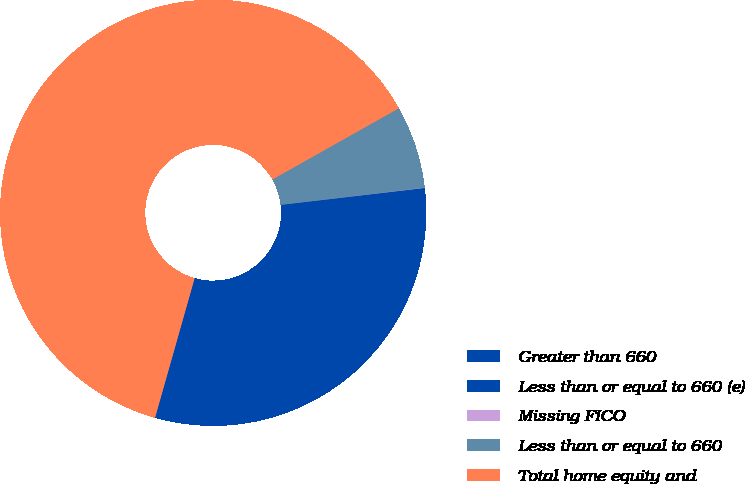Convert chart. <chart><loc_0><loc_0><loc_500><loc_500><pie_chart><fcel>Greater than 660<fcel>Less than or equal to 660 (e)<fcel>Missing FICO<fcel>Less than or equal to 660<fcel>Total home equity and<nl><fcel>18.75%<fcel>12.51%<fcel>0.03%<fcel>6.27%<fcel>62.44%<nl></chart> 